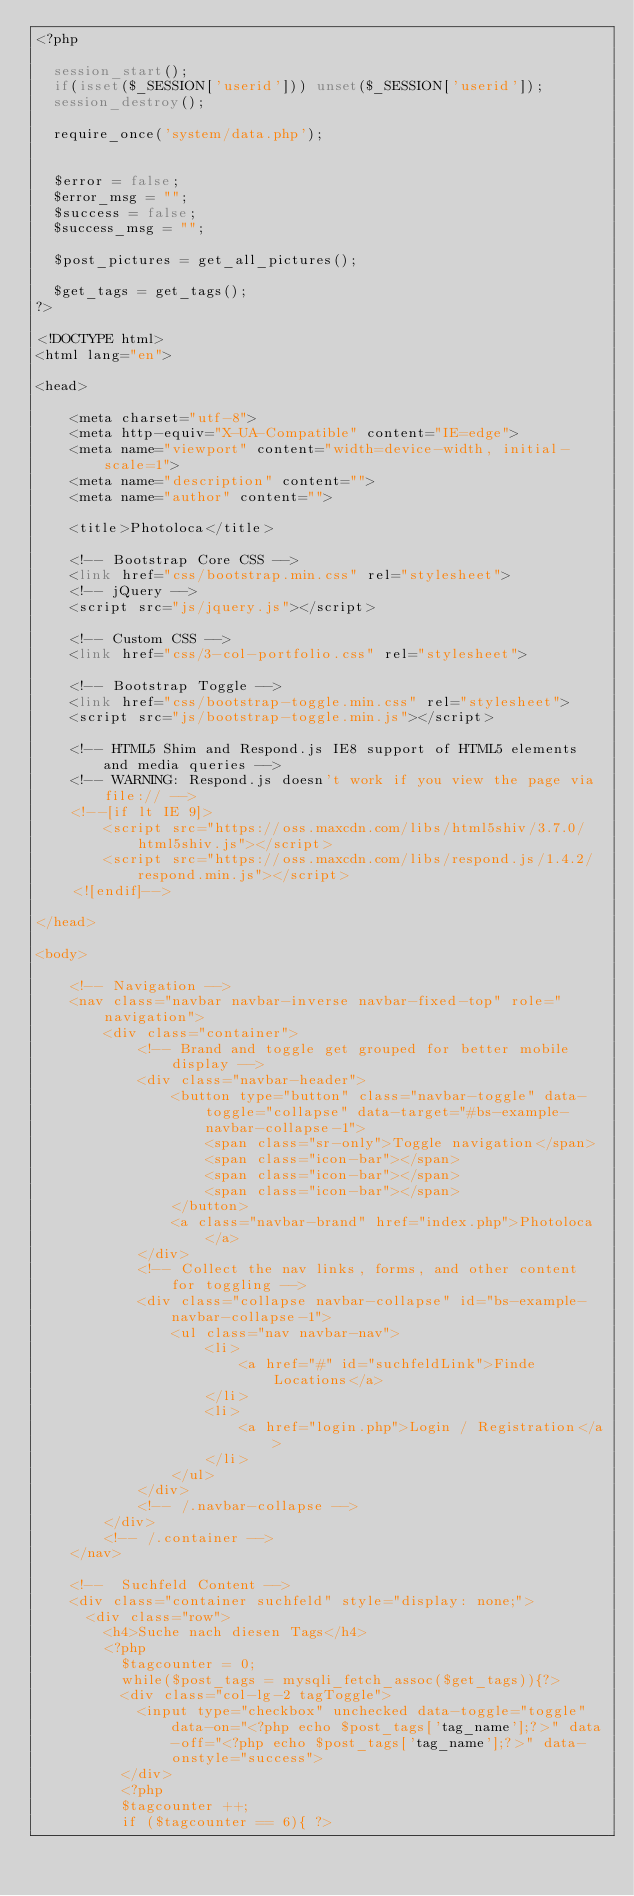<code> <loc_0><loc_0><loc_500><loc_500><_PHP_><?php

  session_start();
  if(isset($_SESSION['userid'])) unset($_SESSION['userid']);
  session_destroy();

  require_once('system/data.php');


  $error = false;
  $error_msg = "";
  $success = false;
  $success_msg = "";

  $post_pictures = get_all_pictures();

  $get_tags = get_tags();
?>

<!DOCTYPE html>
<html lang="en">

<head>

    <meta charset="utf-8">
    <meta http-equiv="X-UA-Compatible" content="IE=edge">
    <meta name="viewport" content="width=device-width, initial-scale=1">
    <meta name="description" content="">
    <meta name="author" content="">

    <title>Photoloca</title>

    <!-- Bootstrap Core CSS -->
    <link href="css/bootstrap.min.css" rel="stylesheet">
    <!-- jQuery -->
    <script src="js/jquery.js"></script>

    <!-- Custom CSS -->
    <link href="css/3-col-portfolio.css" rel="stylesheet">

    <!-- Bootstrap Toggle -->
    <link href="css/bootstrap-toggle.min.css" rel="stylesheet">
    <script src="js/bootstrap-toggle.min.js"></script>

    <!-- HTML5 Shim and Respond.js IE8 support of HTML5 elements and media queries -->
    <!-- WARNING: Respond.js doesn't work if you view the page via file:// -->
    <!--[if lt IE 9]>
        <script src="https://oss.maxcdn.com/libs/html5shiv/3.7.0/html5shiv.js"></script>
        <script src="https://oss.maxcdn.com/libs/respond.js/1.4.2/respond.min.js"></script>
    <![endif]-->

</head>

<body>

    <!-- Navigation -->
    <nav class="navbar navbar-inverse navbar-fixed-top" role="navigation">
        <div class="container">
            <!-- Brand and toggle get grouped for better mobile display -->
            <div class="navbar-header">
                <button type="button" class="navbar-toggle" data-toggle="collapse" data-target="#bs-example-navbar-collapse-1">
                    <span class="sr-only">Toggle navigation</span>
                    <span class="icon-bar"></span>
                    <span class="icon-bar"></span>
                    <span class="icon-bar"></span>
                </button>
                <a class="navbar-brand" href="index.php">Photoloca</a>
            </div>
            <!-- Collect the nav links, forms, and other content for toggling -->
            <div class="collapse navbar-collapse" id="bs-example-navbar-collapse-1">
                <ul class="nav navbar-nav">
                    <li>
                        <a href="#" id="suchfeldLink">Finde Locations</a>
                    </li>
                    <li>
                        <a href="login.php">Login / Registration</a>
                    </li>
                </ul>
            </div>
            <!-- /.navbar-collapse -->
        </div>
        <!-- /.container -->
    </nav>

    <!--  Suchfeld Content -->
    <div class="container suchfeld" style="display: none;">
      <div class="row">
        <h4>Suche nach diesen Tags</h4>
        <?php
          $tagcounter = 0;
          while($post_tags = mysqli_fetch_assoc($get_tags)){?>
          <div class="col-lg-2 tagToggle">
            <input type="checkbox" unchecked data-toggle="toggle" data-on="<?php echo $post_tags['tag_name'];?>" data-off="<?php echo $post_tags['tag_name'];?>" data-onstyle="success">
          </div>
          <?php
          $tagcounter ++;
          if ($tagcounter == 6){ ?></code> 